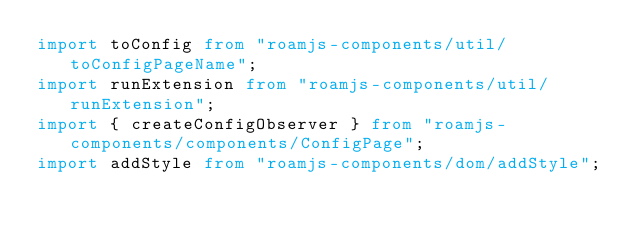Convert code to text. <code><loc_0><loc_0><loc_500><loc_500><_TypeScript_>import toConfig from "roamjs-components/util/toConfigPageName";
import runExtension from "roamjs-components/util/runExtension";
import { createConfigObserver } from "roamjs-components/components/ConfigPage";
import addStyle from "roamjs-components/dom/addStyle";</code> 